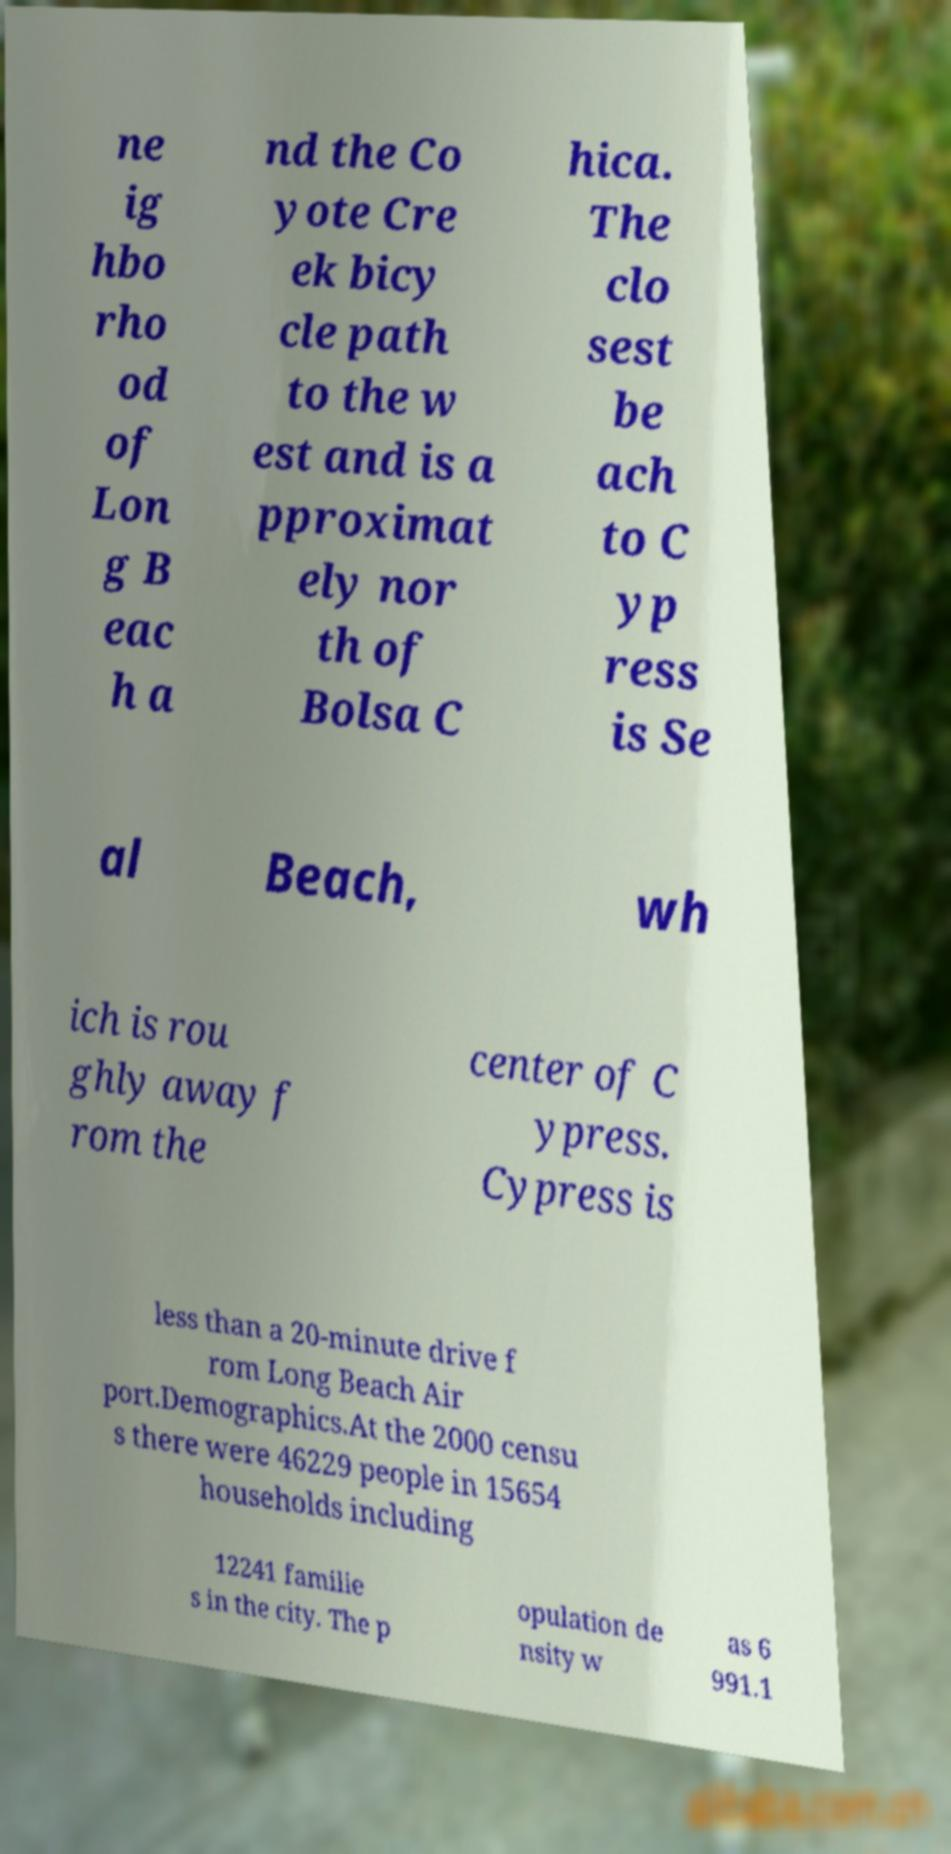Can you accurately transcribe the text from the provided image for me? ne ig hbo rho od of Lon g B eac h a nd the Co yote Cre ek bicy cle path to the w est and is a pproximat ely nor th of Bolsa C hica. The clo sest be ach to C yp ress is Se al Beach, wh ich is rou ghly away f rom the center of C ypress. Cypress is less than a 20-minute drive f rom Long Beach Air port.Demographics.At the 2000 censu s there were 46229 people in 15654 households including 12241 familie s in the city. The p opulation de nsity w as 6 991.1 